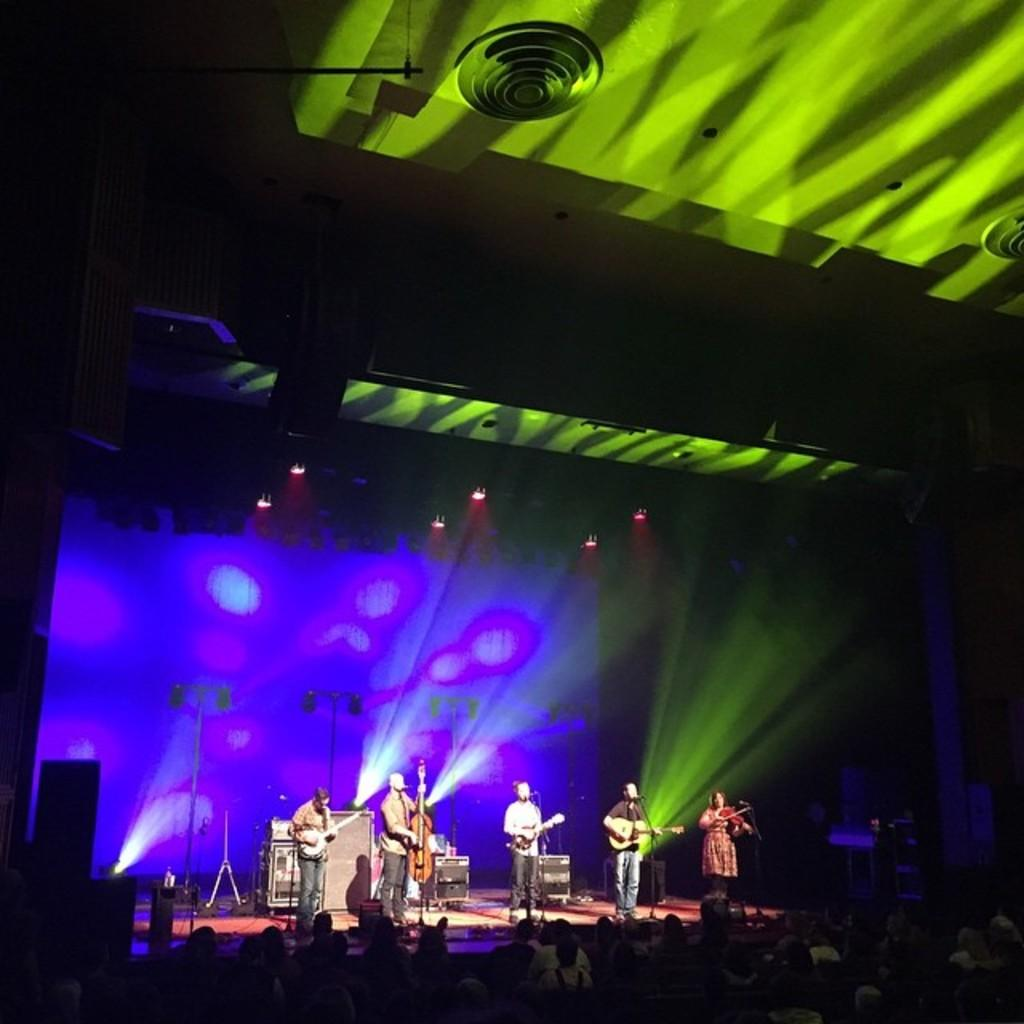How many people are in the image? There is a group of people in the image. What are some of the people doing in the image? Some people are playing musical instruments. What is placed in front of the musicians? There are microphones in front of the musicians. What can be seen in the image that provides illumination? There are lights visible in the image. How many cattle are present in the image? There are no cattle present in the image. What type of agreement was reached by the people in the image? There is no indication of any agreement being reached in the image. 